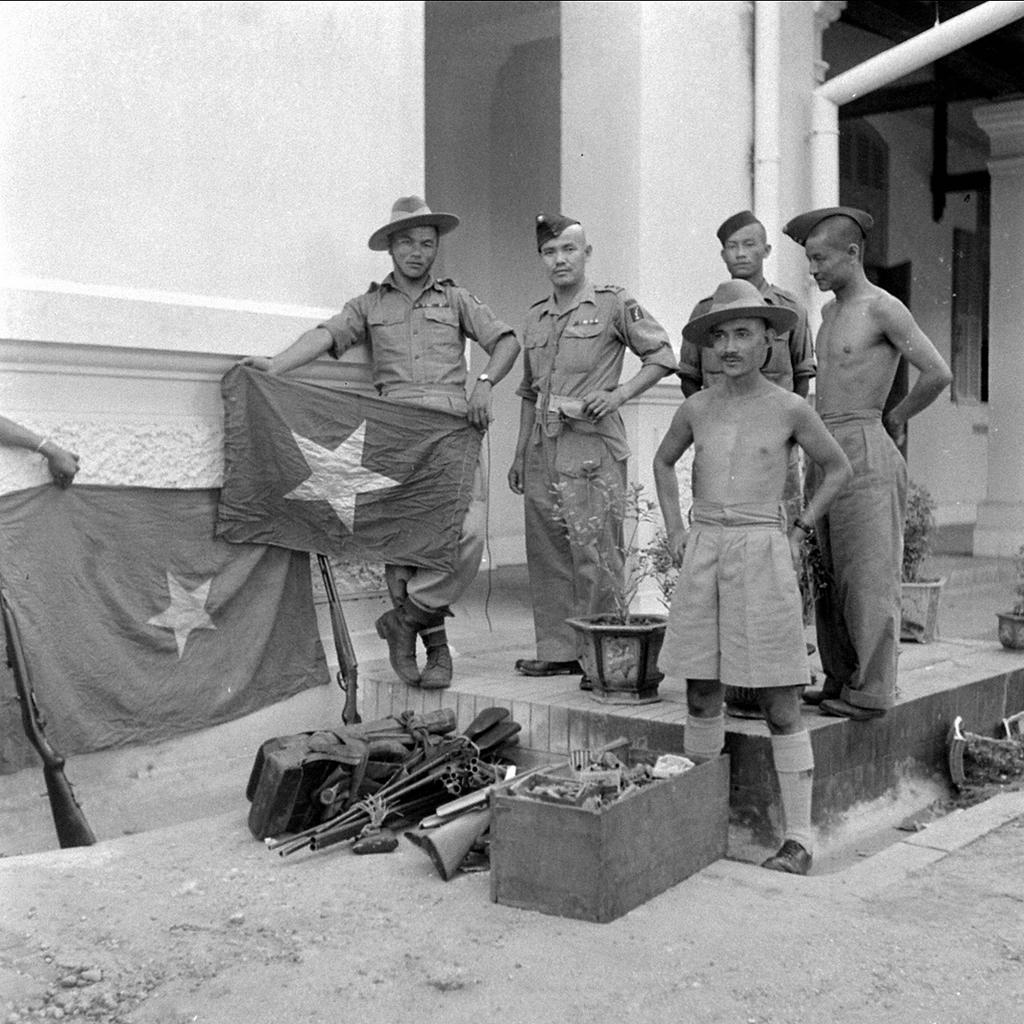What is located in the middle of the picture? There are people, flags, guns, plants, and a box in the middle of the picture. What can be seen in the foreground of the picture? There is soil in the foreground of the picture. What architectural features are visible in the background of the picture? There are pipes, pillars, and a building in the background of the picture. How many hands are visible in the image? There is no specific mention of hands in the image, so it is not possible to determine the number of hands visible. What type of crowd is gathered in the image? There is no mention of a crowd in the image; it features people, flags, guns, plants, a box, soil, pipes, pillars, and a building. 